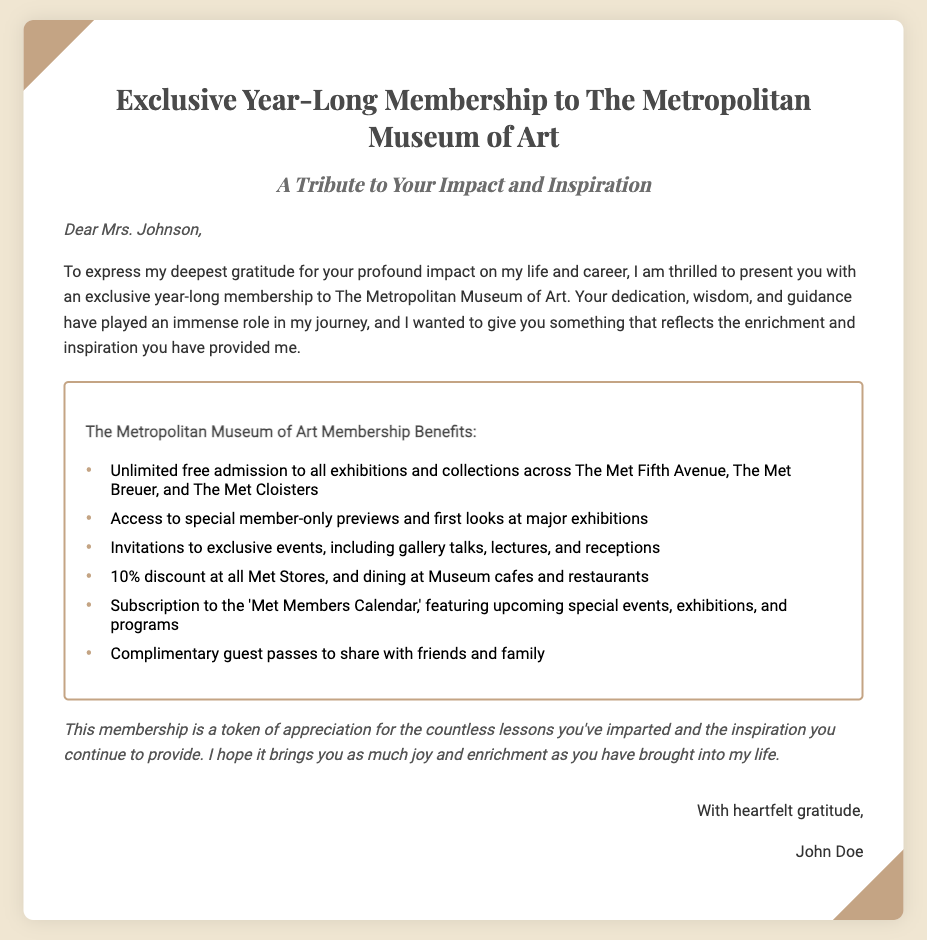What is the name of the cultural institution? The document provides a specific name of the institution that is the subject of the membership.
Answer: The Metropolitan Museum of Art Who is the gift voucher addressed to? The introductory part of the document presents the name of the person to whom the voucher is dedicated.
Answer: Mrs. Johnson What type of membership is being given? The title of the document indicates the specific membership being presented as a gift.
Answer: Year-Long Membership How many benefits are listed in the membership? The document includes a list of benefits, indicating how many there are in total.
Answer: Six What is the discount percentage at Met Stores? One of the benefits mentioned in the document specifies the discount available to members.
Answer: 10% Who is the sender of the gift voucher? The closing section of the document reveals the name of the individual presenting the voucher.
Answer: John Doe What is the purpose of the membership? The introductory and closing parts of the document convey the reason for giving this specific gift.
Answer: A token of appreciation What is mentioned as a feature of the 'Met Members Calendar'? The document states a particular function of the subscription to the 'Met Members Calendar'.
Answer: Upcoming special events Which events are members invited to? The document lists specific types of events that members can attend, summarizing the exclusive opportunities.
Answer: Exclusive events 